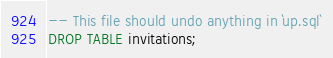<code> <loc_0><loc_0><loc_500><loc_500><_SQL_>-- This file should undo anything in `up.sql`
DROP TABLE invitations;
</code> 